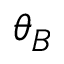Convert formula to latex. <formula><loc_0><loc_0><loc_500><loc_500>\theta _ { B }</formula> 